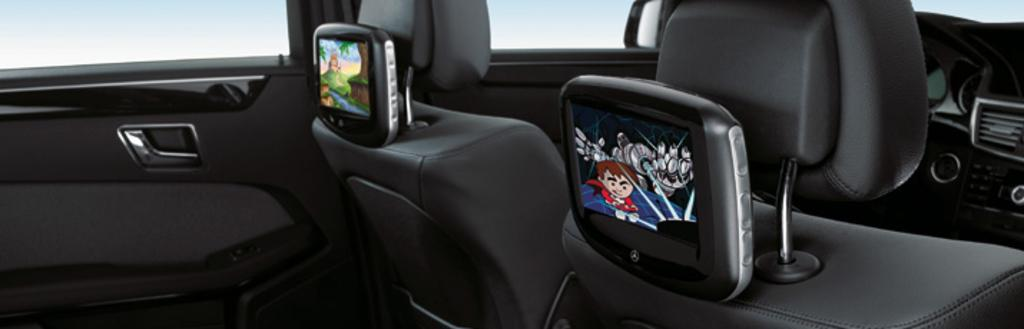What type of vehicle is in the image? There is a vehicle in the image, but the specific type is not mentioned. What features does the vehicle have? The vehicle has seats and mirrors. What can be seen on the screens inside the vehicle? There are two screens displaying something in the vehicle. How does the vehicle lift heavy objects in the image? The vehicle does not lift heavy objects in the image; there is no mention of lifting capabilities. 